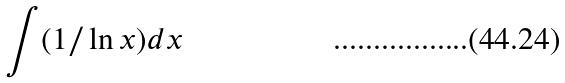Convert formula to latex. <formula><loc_0><loc_0><loc_500><loc_500>\int ( 1 / \ln x ) d x</formula> 